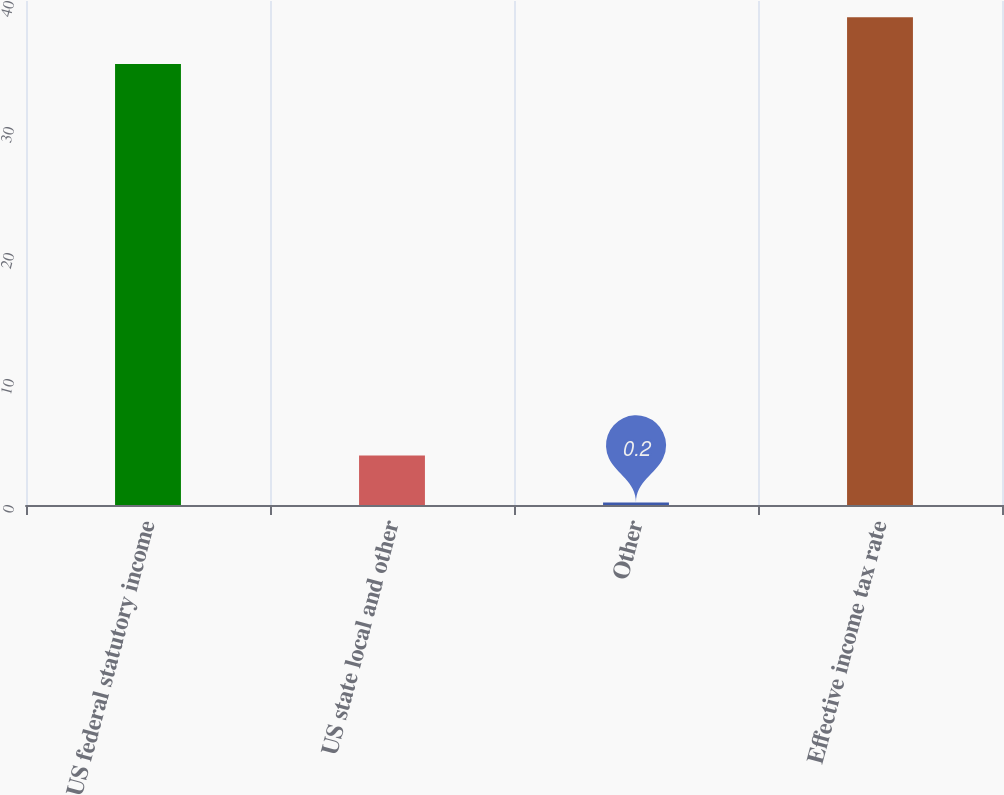Convert chart to OTSL. <chart><loc_0><loc_0><loc_500><loc_500><bar_chart><fcel>US federal statutory income<fcel>US state local and other<fcel>Other<fcel>Effective income tax rate<nl><fcel>35<fcel>3.92<fcel>0.2<fcel>38.72<nl></chart> 